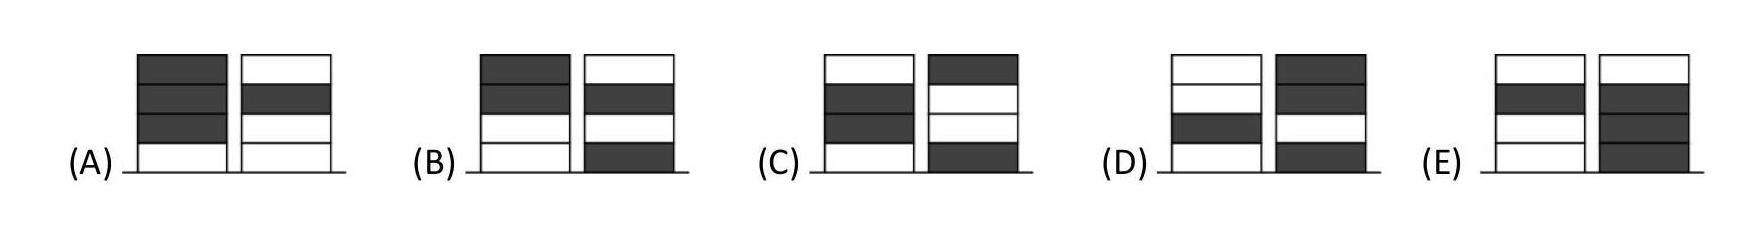If Ronja starts and they want to achieve an equal number in both piles by the end of the game, what is one possibly correct sequence of token placement? A possible sequence could be: Ronja places a white token in pile one, Wanja places a grey token in pile two, Ronja places another white token in pile two, Wanja places a grey token in pile one, and they continue this alternation until each has two tokens in each pile. 